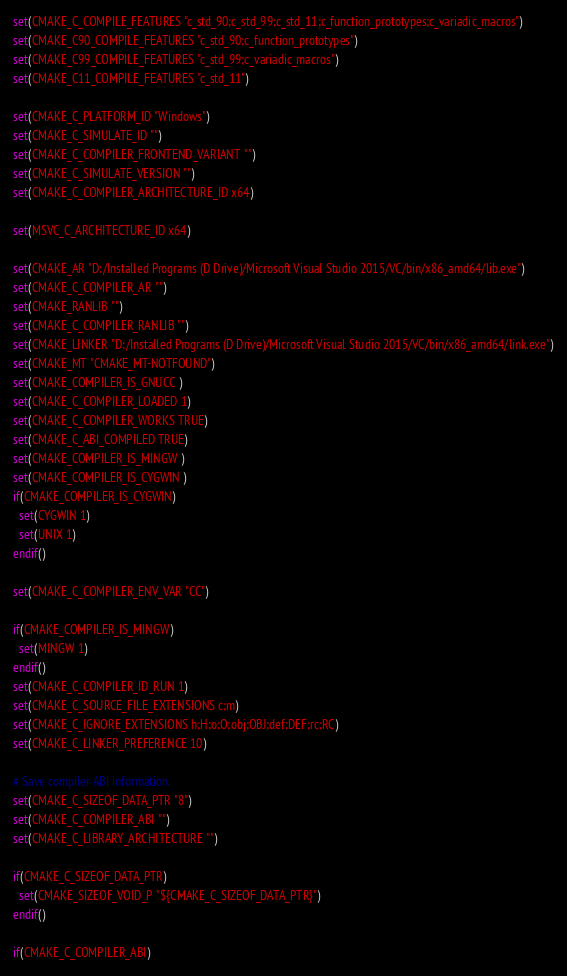Convert code to text. <code><loc_0><loc_0><loc_500><loc_500><_CMake_>set(CMAKE_C_COMPILE_FEATURES "c_std_90;c_std_99;c_std_11;c_function_prototypes;c_variadic_macros")
set(CMAKE_C90_COMPILE_FEATURES "c_std_90;c_function_prototypes")
set(CMAKE_C99_COMPILE_FEATURES "c_std_99;c_variadic_macros")
set(CMAKE_C11_COMPILE_FEATURES "c_std_11")

set(CMAKE_C_PLATFORM_ID "Windows")
set(CMAKE_C_SIMULATE_ID "")
set(CMAKE_C_COMPILER_FRONTEND_VARIANT "")
set(CMAKE_C_SIMULATE_VERSION "")
set(CMAKE_C_COMPILER_ARCHITECTURE_ID x64)

set(MSVC_C_ARCHITECTURE_ID x64)

set(CMAKE_AR "D:/Installed Programs (D Drive)/Microsoft Visual Studio 2015/VC/bin/x86_amd64/lib.exe")
set(CMAKE_C_COMPILER_AR "")
set(CMAKE_RANLIB "")
set(CMAKE_C_COMPILER_RANLIB "")
set(CMAKE_LINKER "D:/Installed Programs (D Drive)/Microsoft Visual Studio 2015/VC/bin/x86_amd64/link.exe")
set(CMAKE_MT "CMAKE_MT-NOTFOUND")
set(CMAKE_COMPILER_IS_GNUCC )
set(CMAKE_C_COMPILER_LOADED 1)
set(CMAKE_C_COMPILER_WORKS TRUE)
set(CMAKE_C_ABI_COMPILED TRUE)
set(CMAKE_COMPILER_IS_MINGW )
set(CMAKE_COMPILER_IS_CYGWIN )
if(CMAKE_COMPILER_IS_CYGWIN)
  set(CYGWIN 1)
  set(UNIX 1)
endif()

set(CMAKE_C_COMPILER_ENV_VAR "CC")

if(CMAKE_COMPILER_IS_MINGW)
  set(MINGW 1)
endif()
set(CMAKE_C_COMPILER_ID_RUN 1)
set(CMAKE_C_SOURCE_FILE_EXTENSIONS c;m)
set(CMAKE_C_IGNORE_EXTENSIONS h;H;o;O;obj;OBJ;def;DEF;rc;RC)
set(CMAKE_C_LINKER_PREFERENCE 10)

# Save compiler ABI information.
set(CMAKE_C_SIZEOF_DATA_PTR "8")
set(CMAKE_C_COMPILER_ABI "")
set(CMAKE_C_LIBRARY_ARCHITECTURE "")

if(CMAKE_C_SIZEOF_DATA_PTR)
  set(CMAKE_SIZEOF_VOID_P "${CMAKE_C_SIZEOF_DATA_PTR}")
endif()

if(CMAKE_C_COMPILER_ABI)</code> 